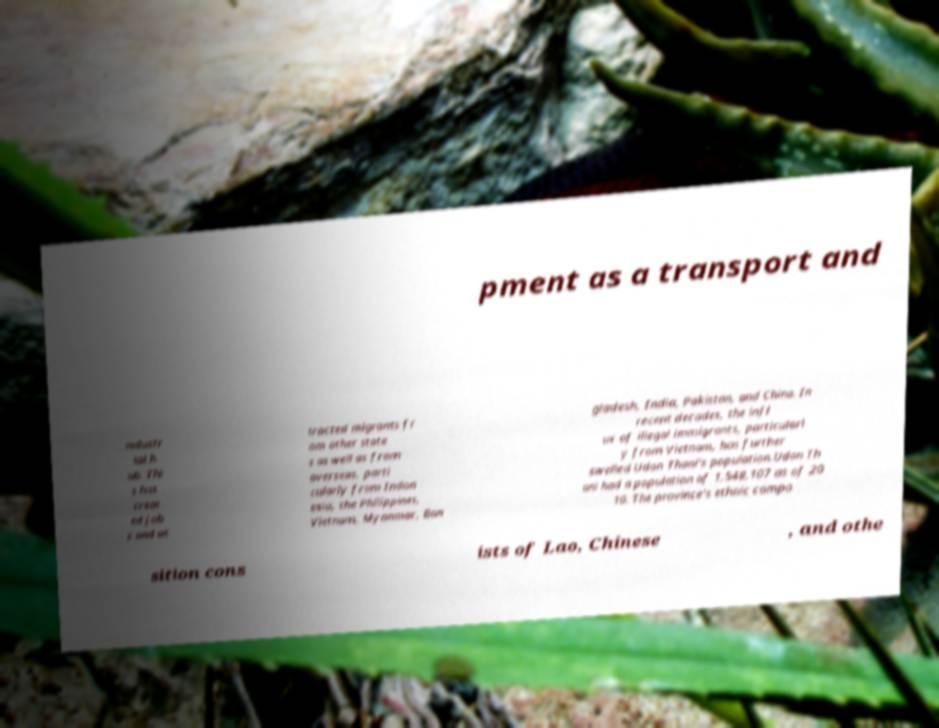Please identify and transcribe the text found in this image. pment as a transport and industr ial h ub. Thi s has creat ed job s and at tracted migrants fr om other state s as well as from overseas, parti cularly from Indon esia, the Philippines, Vietnam, Myanmar, Ban gladesh, India, Pakistan, and China. In recent decades, the infl ux of illegal immigrants, particularl y from Vietnam, has further swelled Udon Thani's population.Udon Th ani had a population of 1,548,107 as of 20 10. The province's ethnic compo sition cons ists of Lao, Chinese , and othe 